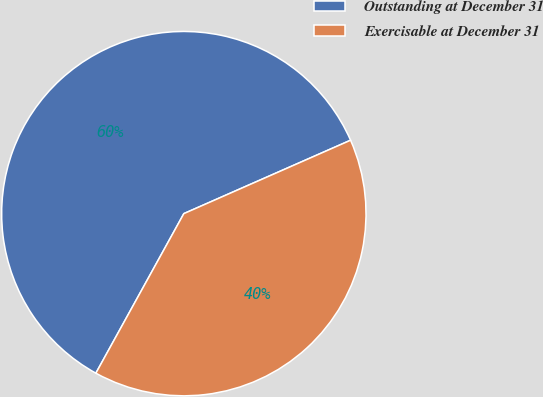Convert chart to OTSL. <chart><loc_0><loc_0><loc_500><loc_500><pie_chart><fcel>Outstanding at December 31<fcel>Exercisable at December 31<nl><fcel>60.38%<fcel>39.62%<nl></chart> 